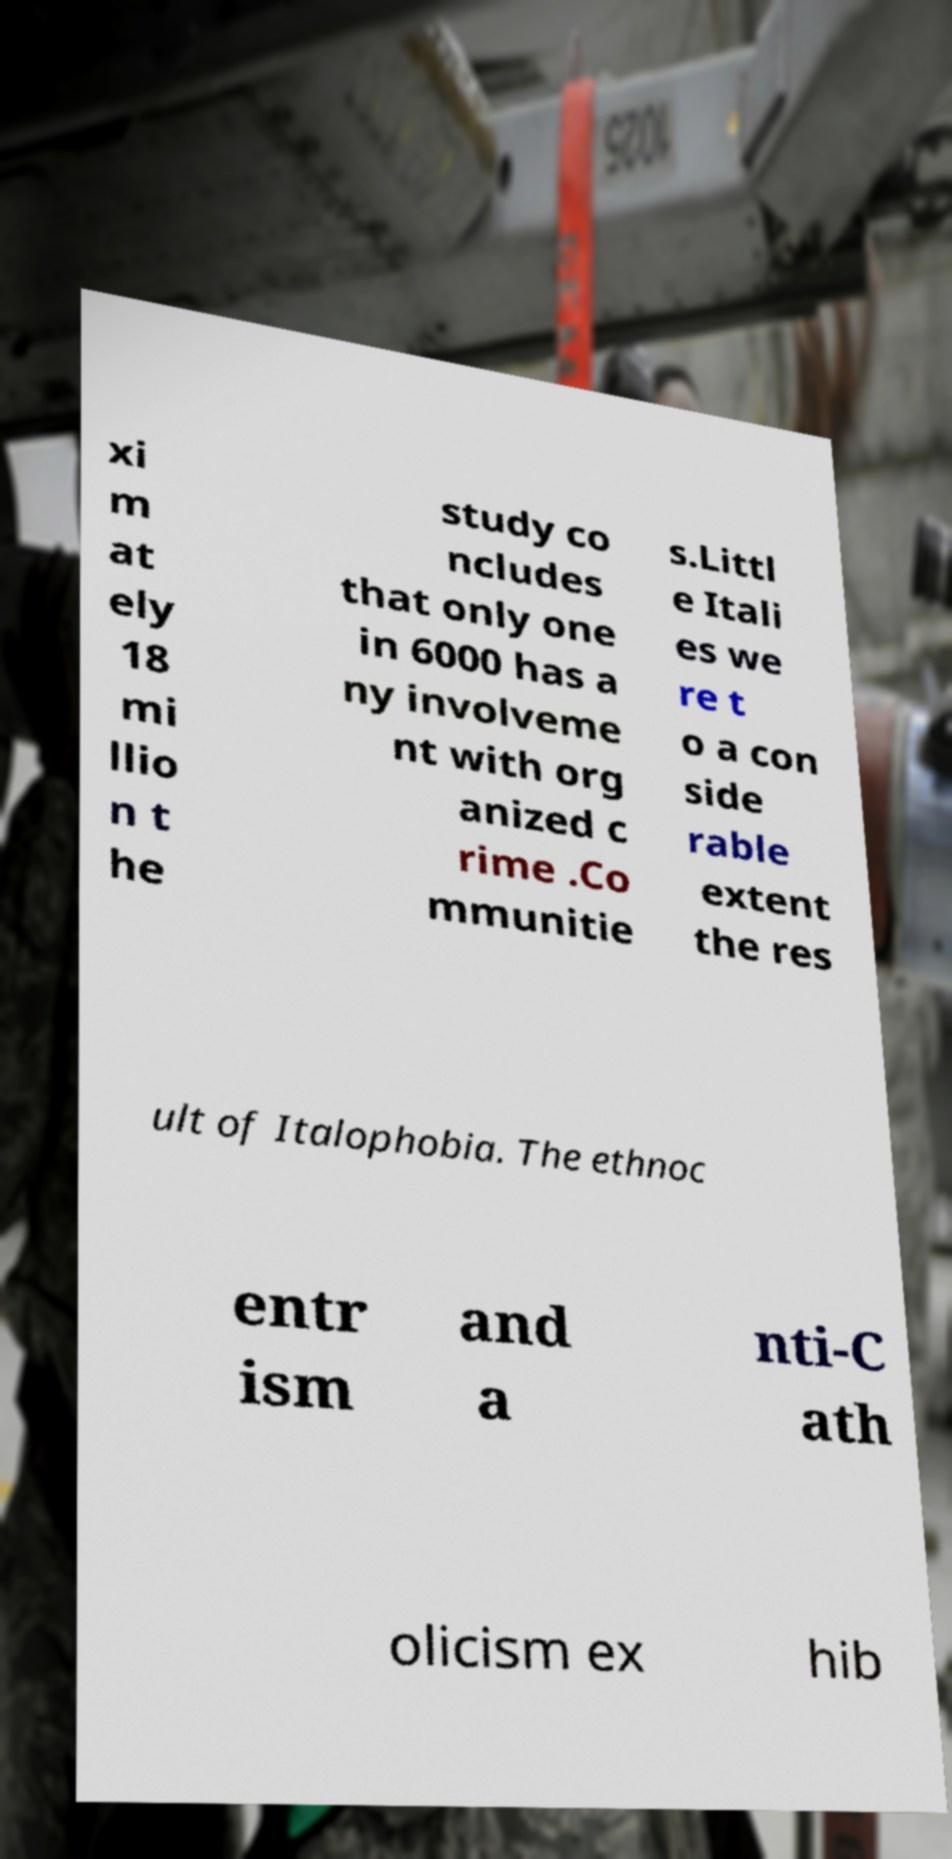Please identify and transcribe the text found in this image. xi m at ely 18 mi llio n t he study co ncludes that only one in 6000 has a ny involveme nt with org anized c rime .Co mmunitie s.Littl e Itali es we re t o a con side rable extent the res ult of Italophobia. The ethnoc entr ism and a nti-C ath olicism ex hib 